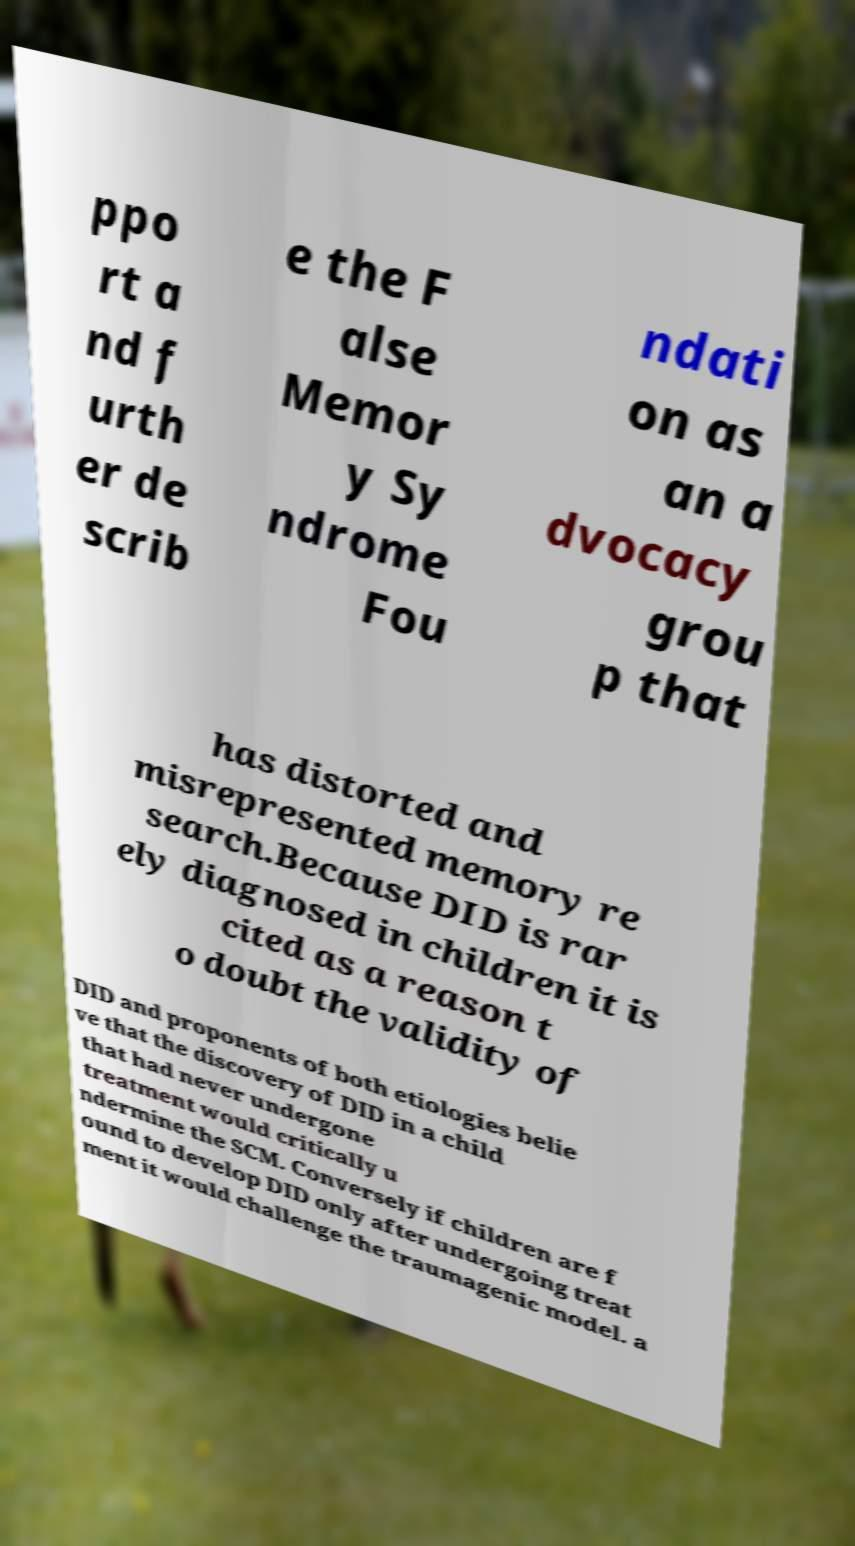Can you accurately transcribe the text from the provided image for me? ppo rt a nd f urth er de scrib e the F alse Memor y Sy ndrome Fou ndati on as an a dvocacy grou p that has distorted and misrepresented memory re search.Because DID is rar ely diagnosed in children it is cited as a reason t o doubt the validity of DID and proponents of both etiologies belie ve that the discovery of DID in a child that had never undergone treatment would critically u ndermine the SCM. Conversely if children are f ound to develop DID only after undergoing treat ment it would challenge the traumagenic model. a 